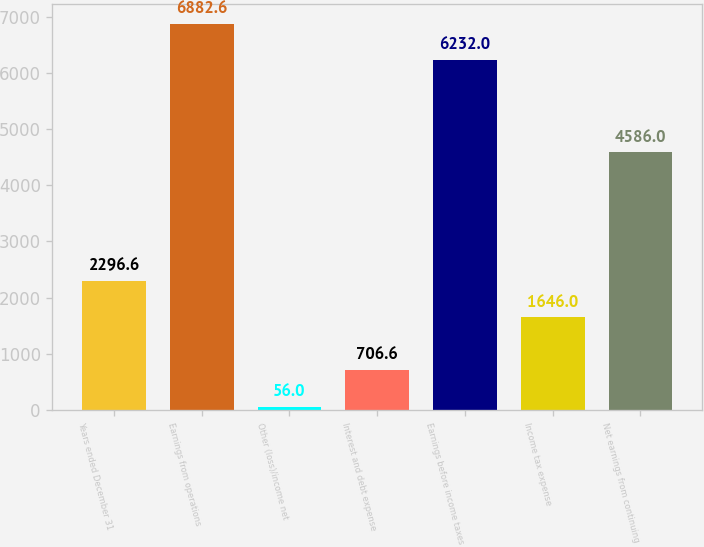<chart> <loc_0><loc_0><loc_500><loc_500><bar_chart><fcel>Years ended December 31<fcel>Earnings from operations<fcel>Other (loss)/income net<fcel>Interest and debt expense<fcel>Earnings before income taxes<fcel>Income tax expense<fcel>Net earnings from continuing<nl><fcel>2296.6<fcel>6882.6<fcel>56<fcel>706.6<fcel>6232<fcel>1646<fcel>4586<nl></chart> 